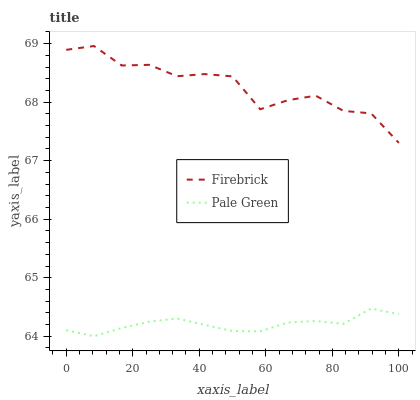Does Pale Green have the minimum area under the curve?
Answer yes or no. Yes. Does Firebrick have the maximum area under the curve?
Answer yes or no. Yes. Does Pale Green have the maximum area under the curve?
Answer yes or no. No. Is Pale Green the smoothest?
Answer yes or no. Yes. Is Firebrick the roughest?
Answer yes or no. Yes. Is Pale Green the roughest?
Answer yes or no. No. Does Pale Green have the lowest value?
Answer yes or no. Yes. Does Firebrick have the highest value?
Answer yes or no. Yes. Does Pale Green have the highest value?
Answer yes or no. No. Is Pale Green less than Firebrick?
Answer yes or no. Yes. Is Firebrick greater than Pale Green?
Answer yes or no. Yes. Does Pale Green intersect Firebrick?
Answer yes or no. No. 